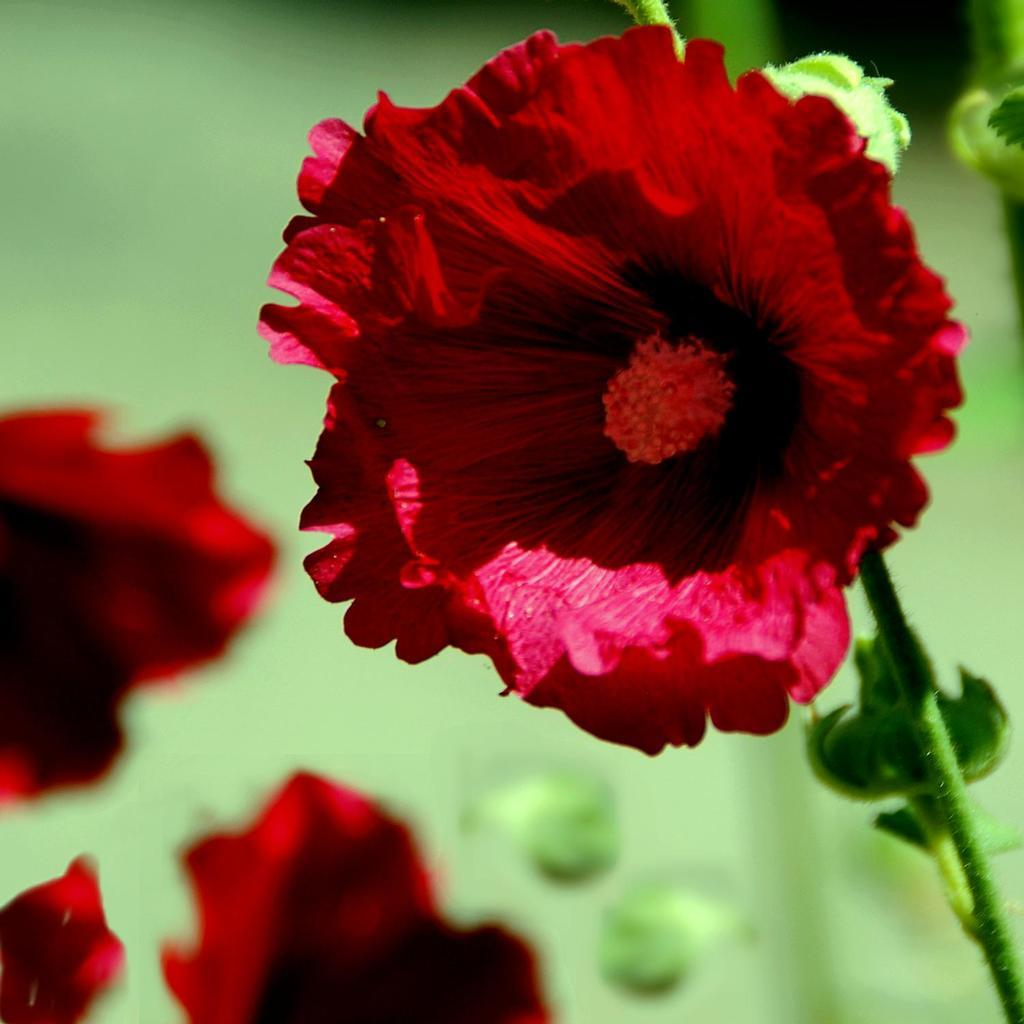What is the main subject of the image? There is a plant in the center of the image. What specific feature of the plant can be observed? The plant has flowers. What color are the flowers? The flowers are red in color. Can you describe the background of the image? The background of the image is blurred. How does the plant aid in the digestion of cattle in the image? There is no mention of cattle or digestion in the image, as it only features a plant with red flowers and a blurred background. 